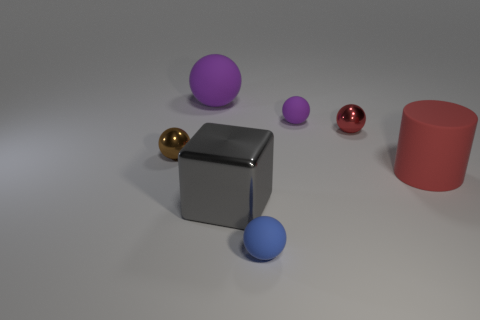What number of big rubber cylinders are the same color as the big sphere?
Offer a very short reply. 0. There is a big metal block; is its color the same as the matte object to the right of the small purple matte object?
Provide a succinct answer. No. What number of things are big things or small matte things in front of the large red rubber cylinder?
Offer a very short reply. 4. There is a purple ball to the left of the big gray thing that is in front of the tiny red sphere; how big is it?
Offer a terse response. Large. Is the number of tiny brown balls that are in front of the tiny blue object the same as the number of matte balls to the right of the small red object?
Provide a succinct answer. Yes. There is a tiny object behind the tiny red shiny thing; is there a small purple rubber sphere that is behind it?
Your response must be concise. No. The blue object that is made of the same material as the cylinder is what shape?
Provide a short and direct response. Sphere. Is there anything else that is the same color as the large cylinder?
Offer a terse response. Yes. The purple ball to the left of the thing that is in front of the gray cube is made of what material?
Offer a very short reply. Rubber. Are there any red objects of the same shape as the big gray metal thing?
Give a very brief answer. No. 